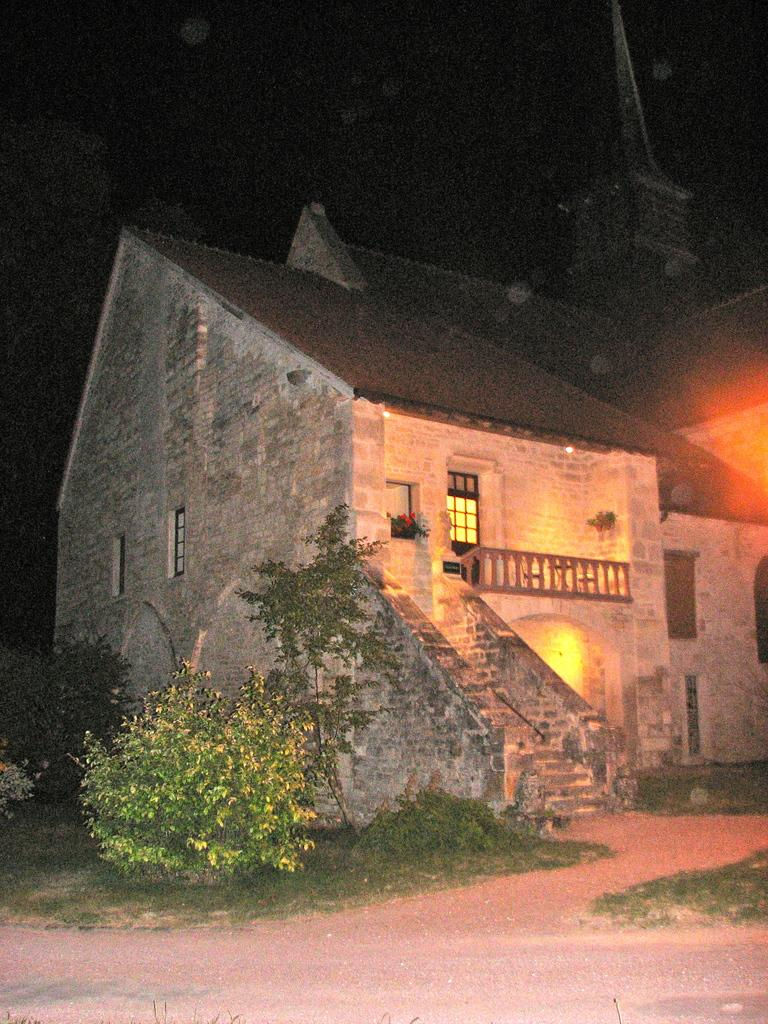What type of structure is present in the image? There is a building in the image. What can be seen in front of the building? There are trees, plants, and grass in front of the building. What is visible in the background of the image? The sky is visible in the image. What is the governor doing in the image? There is no governor present in the image. How does the shame affect the plants in the image? There is no shame present in the image, and the plants are not affected by any emotions. 